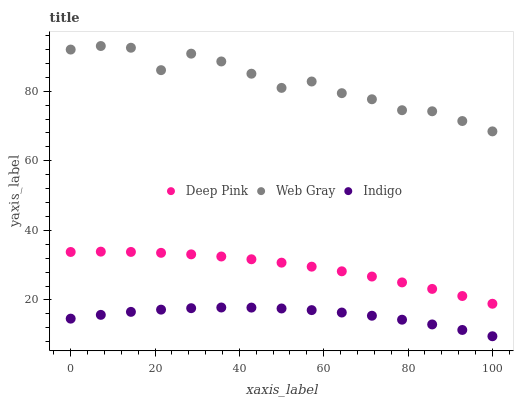Does Indigo have the minimum area under the curve?
Answer yes or no. Yes. Does Web Gray have the maximum area under the curve?
Answer yes or no. Yes. Does Deep Pink have the minimum area under the curve?
Answer yes or no. No. Does Deep Pink have the maximum area under the curve?
Answer yes or no. No. Is Deep Pink the smoothest?
Answer yes or no. Yes. Is Web Gray the roughest?
Answer yes or no. Yes. Is Web Gray the smoothest?
Answer yes or no. No. Is Deep Pink the roughest?
Answer yes or no. No. Does Indigo have the lowest value?
Answer yes or no. Yes. Does Deep Pink have the lowest value?
Answer yes or no. No. Does Web Gray have the highest value?
Answer yes or no. Yes. Does Deep Pink have the highest value?
Answer yes or no. No. Is Indigo less than Deep Pink?
Answer yes or no. Yes. Is Deep Pink greater than Indigo?
Answer yes or no. Yes. Does Indigo intersect Deep Pink?
Answer yes or no. No. 